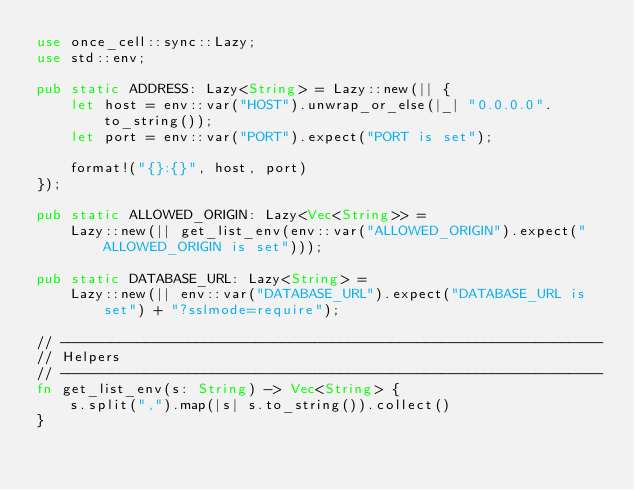<code> <loc_0><loc_0><loc_500><loc_500><_Rust_>use once_cell::sync::Lazy;
use std::env;

pub static ADDRESS: Lazy<String> = Lazy::new(|| {
    let host = env::var("HOST").unwrap_or_else(|_| "0.0.0.0".to_string());
    let port = env::var("PORT").expect("PORT is set");

    format!("{}:{}", host, port)
});

pub static ALLOWED_ORIGIN: Lazy<Vec<String>> =
    Lazy::new(|| get_list_env(env::var("ALLOWED_ORIGIN").expect("ALLOWED_ORIGIN is set")));

pub static DATABASE_URL: Lazy<String> =
    Lazy::new(|| env::var("DATABASE_URL").expect("DATABASE_URL is set") + "?sslmode=require");

// ----------------------------------------------------------------
// Helpers
// ----------------------------------------------------------------
fn get_list_env(s: String) -> Vec<String> {
    s.split(",").map(|s| s.to_string()).collect()
}
</code> 